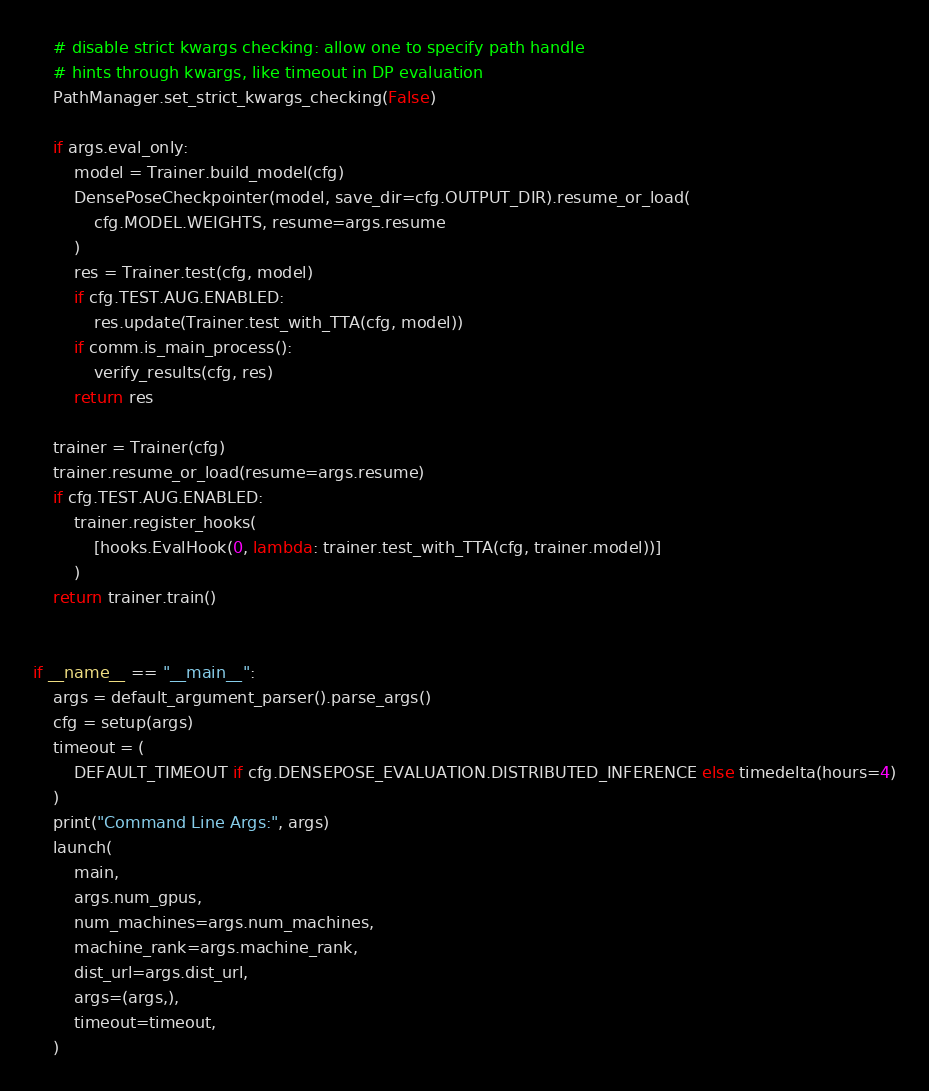<code> <loc_0><loc_0><loc_500><loc_500><_Python_>    # disable strict kwargs checking: allow one to specify path handle
    # hints through kwargs, like timeout in DP evaluation
    PathManager.set_strict_kwargs_checking(False)

    if args.eval_only:
        model = Trainer.build_model(cfg)
        DensePoseCheckpointer(model, save_dir=cfg.OUTPUT_DIR).resume_or_load(
            cfg.MODEL.WEIGHTS, resume=args.resume
        )
        res = Trainer.test(cfg, model)
        if cfg.TEST.AUG.ENABLED:
            res.update(Trainer.test_with_TTA(cfg, model))
        if comm.is_main_process():
            verify_results(cfg, res)
        return res

    trainer = Trainer(cfg)
    trainer.resume_or_load(resume=args.resume)
    if cfg.TEST.AUG.ENABLED:
        trainer.register_hooks(
            [hooks.EvalHook(0, lambda: trainer.test_with_TTA(cfg, trainer.model))]
        )
    return trainer.train()


if __name__ == "__main__":
    args = default_argument_parser().parse_args()
    cfg = setup(args)
    timeout = (
        DEFAULT_TIMEOUT if cfg.DENSEPOSE_EVALUATION.DISTRIBUTED_INFERENCE else timedelta(hours=4)
    )
    print("Command Line Args:", args)
    launch(
        main,
        args.num_gpus,
        num_machines=args.num_machines,
        machine_rank=args.machine_rank,
        dist_url=args.dist_url,
        args=(args,),
        timeout=timeout,
    )
</code> 